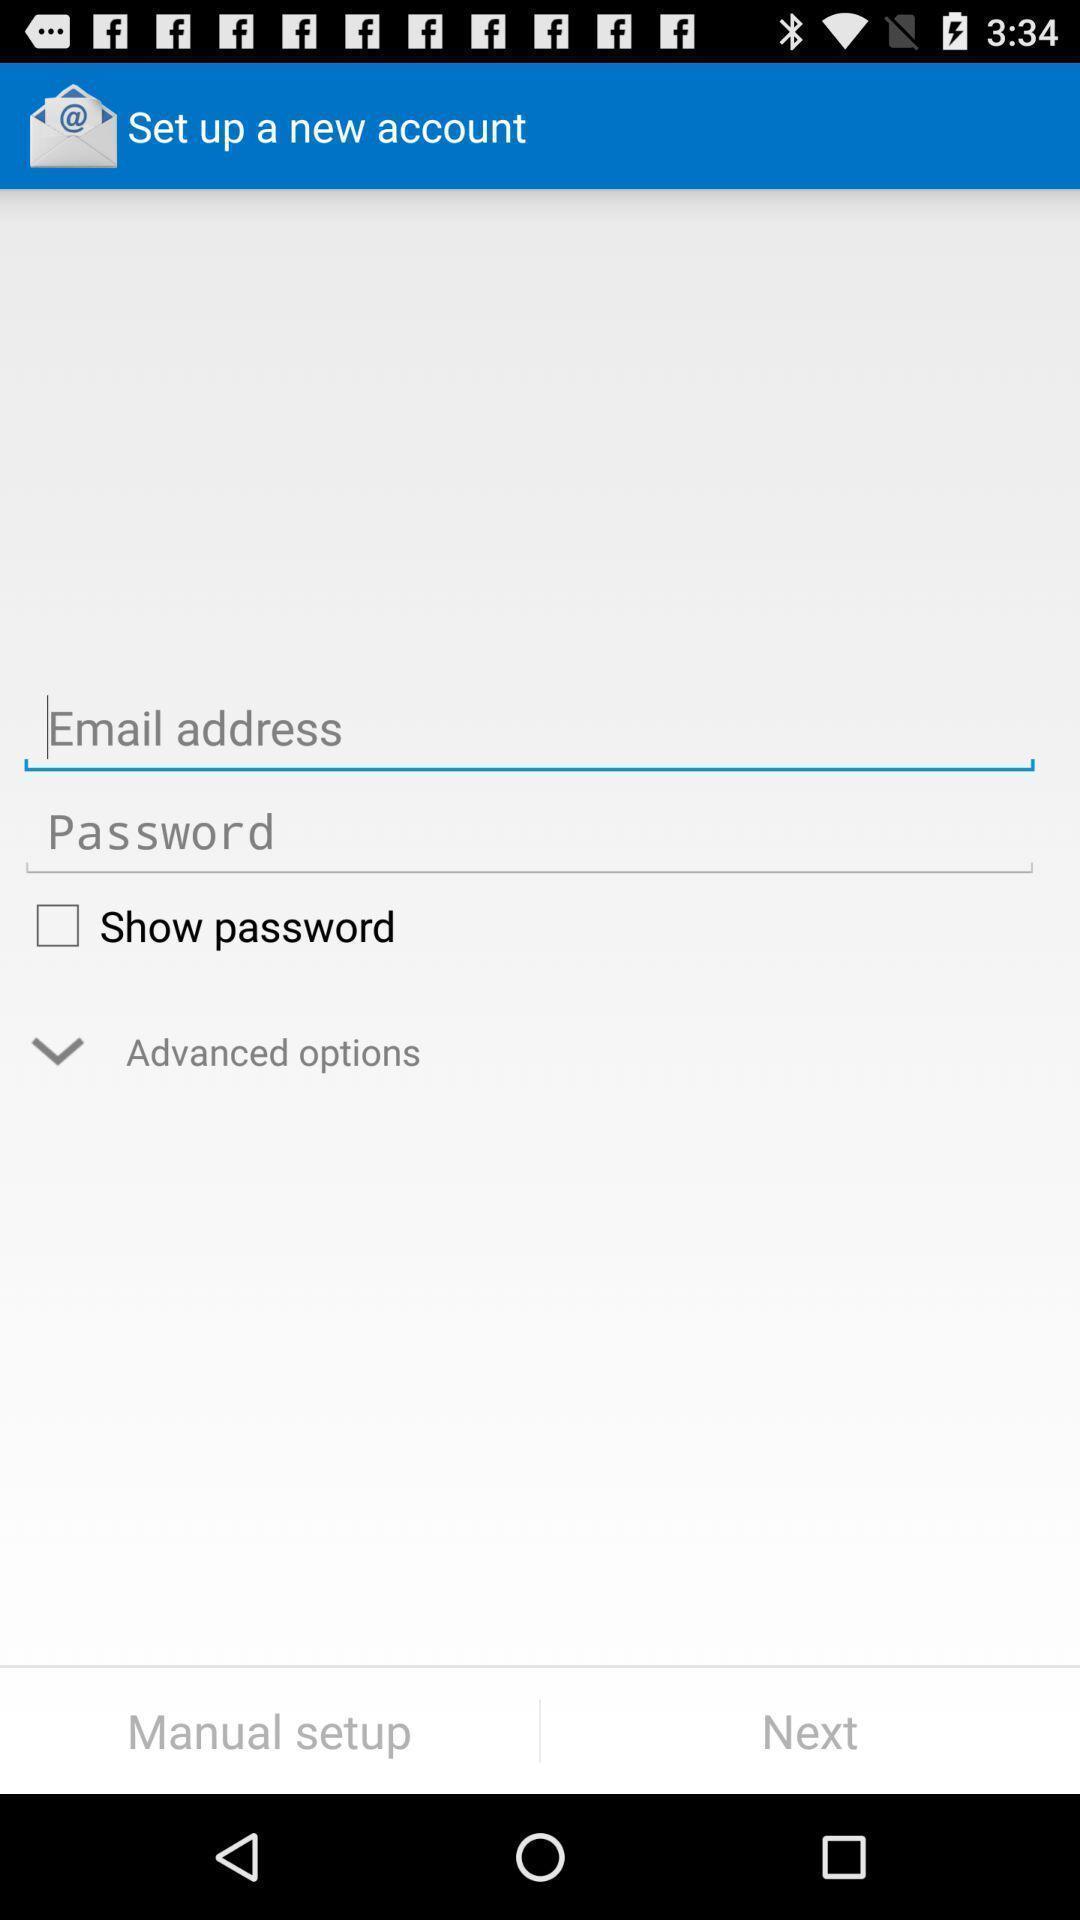Describe the visual elements of this screenshot. Welcome page to set up new account. 